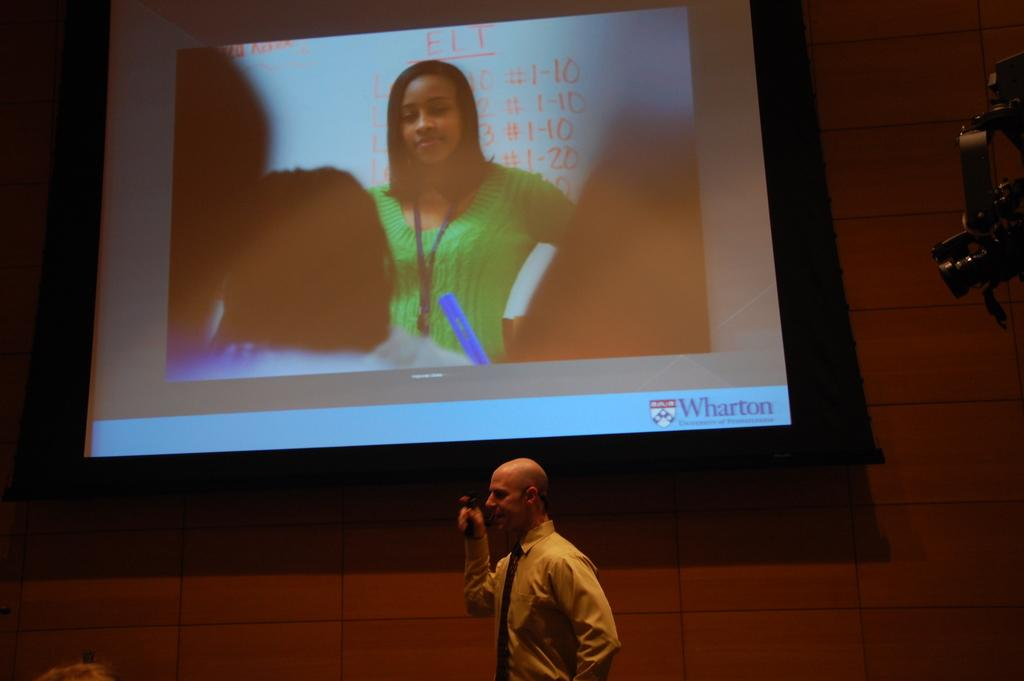What is the man doing at the bottom of the image? The man is standing and talking at the bottom of the image. What object can be seen on the right side of the image? There is a camera on the right side of the image. What is located in the center of the image? There is a screen in the center of the image. What can be seen in the background of the image? There is a wall in the background of the image. What type of soda is being served at the competition in the image? There is no mention of a competition or soda in the image; it only features a man talking, a camera, a screen, and a wall in the background. 